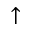<formula> <loc_0><loc_0><loc_500><loc_500>\uparrow</formula> 